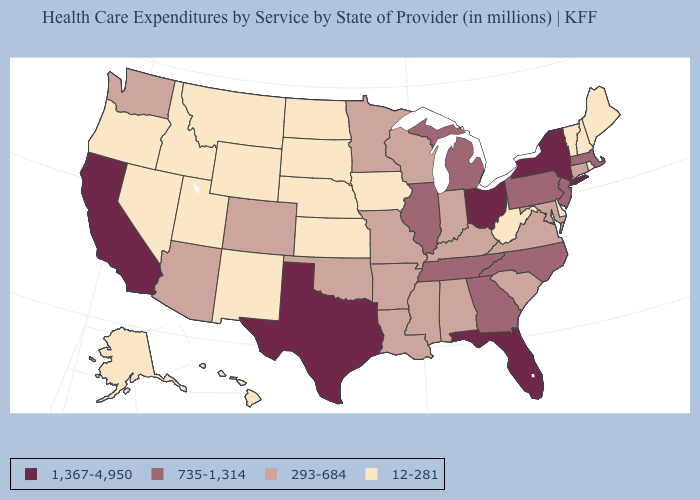How many symbols are there in the legend?
Quick response, please. 4. What is the value of Louisiana?
Write a very short answer. 293-684. Is the legend a continuous bar?
Keep it brief. No. Does the map have missing data?
Concise answer only. No. Among the states that border Michigan , which have the lowest value?
Keep it brief. Indiana, Wisconsin. Among the states that border North Carolina , does Tennessee have the highest value?
Keep it brief. Yes. What is the highest value in the MidWest ?
Give a very brief answer. 1,367-4,950. What is the value of Arizona?
Answer briefly. 293-684. Among the states that border Missouri , which have the lowest value?
Answer briefly. Iowa, Kansas, Nebraska. Does Ohio have the highest value in the USA?
Give a very brief answer. Yes. What is the value of Florida?
Concise answer only. 1,367-4,950. Name the states that have a value in the range 293-684?
Short answer required. Alabama, Arizona, Arkansas, Colorado, Connecticut, Indiana, Kentucky, Louisiana, Maryland, Minnesota, Mississippi, Missouri, Oklahoma, South Carolina, Virginia, Washington, Wisconsin. Does Kansas have a lower value than Wisconsin?
Be succinct. Yes. Does the map have missing data?
Give a very brief answer. No. Which states have the lowest value in the USA?
Concise answer only. Alaska, Delaware, Hawaii, Idaho, Iowa, Kansas, Maine, Montana, Nebraska, Nevada, New Hampshire, New Mexico, North Dakota, Oregon, Rhode Island, South Dakota, Utah, Vermont, West Virginia, Wyoming. 